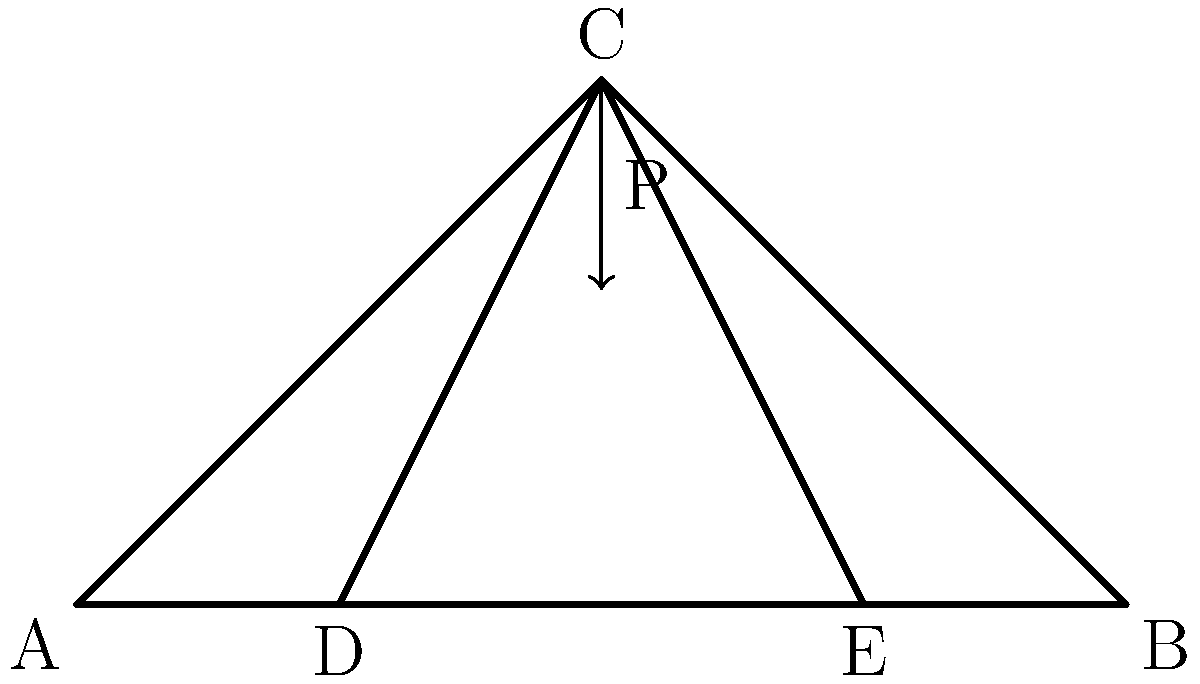As a sports coach analyzing structural efficiency for a new stadium, you encounter a simple truss design as shown. Which member of this truss experiences the highest compressive force when a vertical load P is applied at point C, and why is this knowledge crucial for optimizing the structure's performance? To determine the member with the highest compressive force, we'll analyze the truss step-by-step:

1. Identify the type of truss: This is a Warren truss, commonly used in bridge and roof designs.

2. Analyze load transfer:
   - The vertical load P at point C is transferred to the supports at A and B.
   - Due to symmetry, each support receives half the load (P/2).

3. Examine force distribution:
   - The top chord members (AC and CB) are in compression.
   - The bottom chord members (AD, DE, and EB) are in tension.
   - The web members (CD and CE) are in compression.

4. Compare member forces:
   - The top chord members (AC and CB) bear the highest compressive force.
   - This is because they resist the bending moment created by the load.
   - The compressive force in these members can be approximated as:
     $F = \frac{PL}{4h}$
     where L is the span length and h is the truss height.

5. Importance for structural optimization:
   - Knowing the highest compressive force helps in selecting appropriate materials and cross-sectional areas for each member.
   - It allows for efficient use of materials, reducing costs and weight while maintaining structural integrity.
   - This knowledge is crucial for ensuring safety and longevity of the structure under various load conditions.

Understanding this concept is vital for a sports coach analyzing stadium structures, as it directly impacts the safety, cost-effectiveness, and long-term performance of the facility.
Answer: Top chord members (AC and CB) 